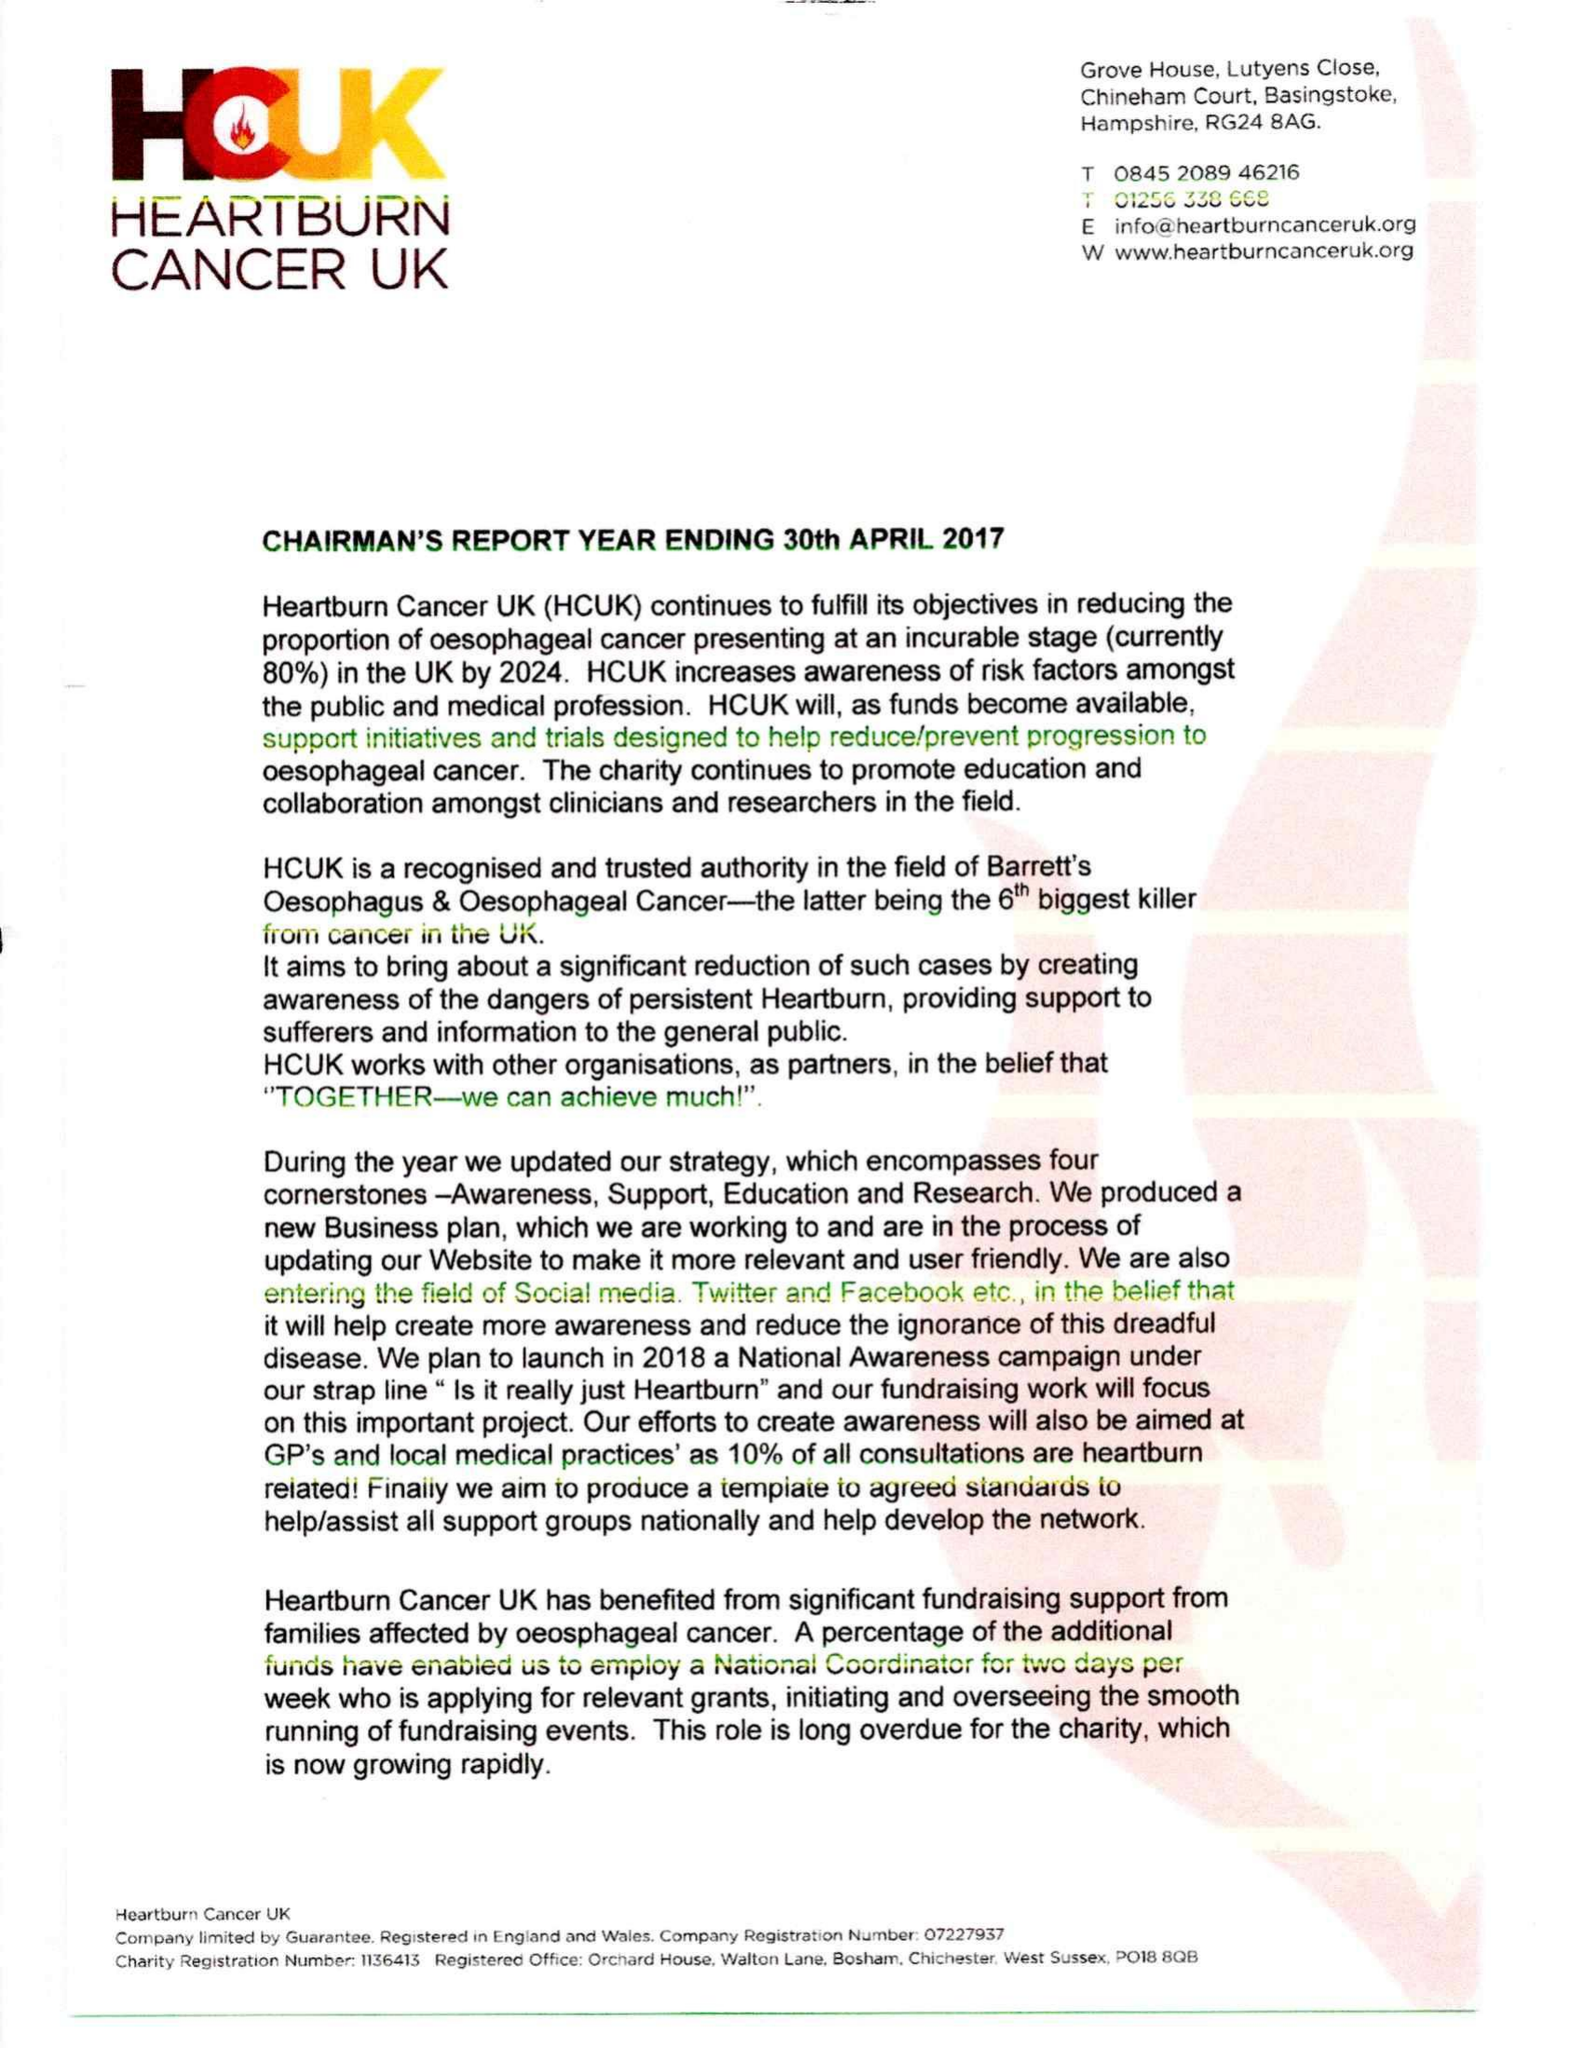What is the value for the spending_annually_in_british_pounds?
Answer the question using a single word or phrase. 7045.00 